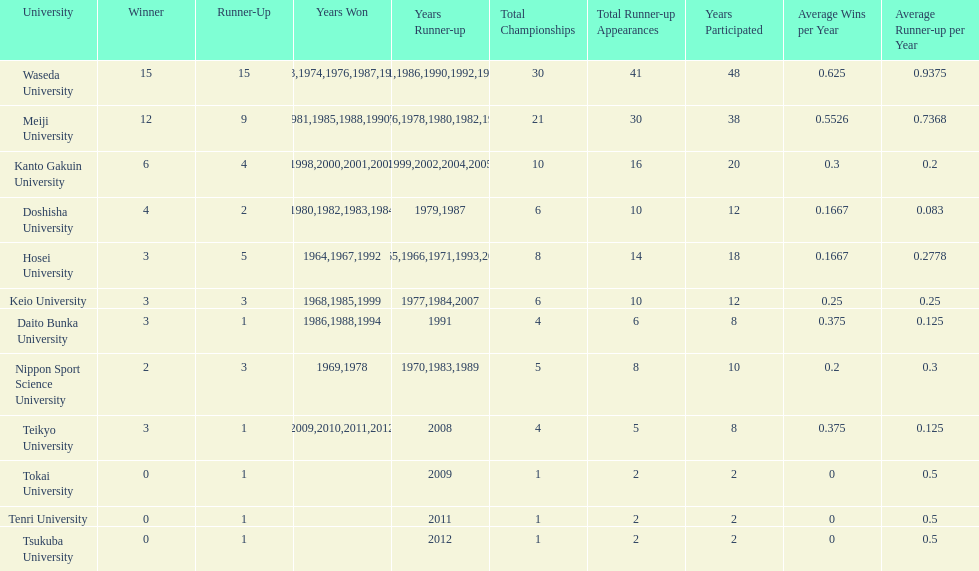Can you give me this table as a dict? {'header': ['University', 'Winner', 'Runner-Up', 'Years Won', 'Years Runner-up', 'Total Championships', 'Total Runner-up Appearances', 'Years Participated', 'Average Wins per Year', 'Average Runner-up per Year'], 'rows': [['Waseda University', '15', '15', '1965,1966,1968,1970,1971,1973,1974,1976,1987,1989,\\n2002,2004,2005,2007,2008', '1964,1967,1969,1972,1975,1981,1986,1990,1992,1995,\\n1996,2001,2003,2006,2010', '30', '41', '48', '0.625', '0.9375'], ['Meiji University', '12', '9', '1972,1975,1977,1979,1981,1985,1988,1990,1991,1993,\\n1995,1996', '1973,1974,1976,1978,1980,1982,1994,1997,1998', '21', '30', '38', '0.5526', '0.7368'], ['Kanto Gakuin University', '6', '4', '1997,1998,2000,2001,2003,2006', '1999,2002,2004,2005', '10', '16', '20', '0.3', '0.2'], ['Doshisha University', '4', '2', '1980,1982,1983,1984', '1979,1987', '6', '10', '12', '0.1667', '0.083'], ['Hosei University', '3', '5', '1964,1967,1992', '1965,1966,1971,1993,2000', '8', '14', '18', '0.1667', '0.2778'], ['Keio University', '3', '3', '1968,1985,1999', '1977,1984,2007', '6', '10', '12', '0.25', '0.25'], ['Daito Bunka University', '3', '1', '1986,1988,1994', '1991', '4', '6', '8', '0.375', '0.125'], ['Nippon Sport Science University', '2', '3', '1969,1978', '1970,1983,1989', '5', '8', '10', '0.2', '0.3'], ['Teikyo University', '3', '1', '2009,2010,2011,2012', '2008', '4', '5', '8', '0.375', '0.125'], ['Tokai University', '0', '1', '', '2009', '1', '2', '2', '0', '0.5'], ['Tenri University', '0', '1', '', '2011', '1', '2', '2', '0', '0.5'], ['Tsukuba University', '0', '1', '', '2012', '1', '2', '2', '0', '0.5']]} How many championships does nippon sport science university have 2. 